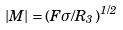Convert formula to latex. <formula><loc_0><loc_0><loc_500><loc_500>| M | = \left ( F \sigma / R _ { 3 } \right ) ^ { 1 / 2 }</formula> 